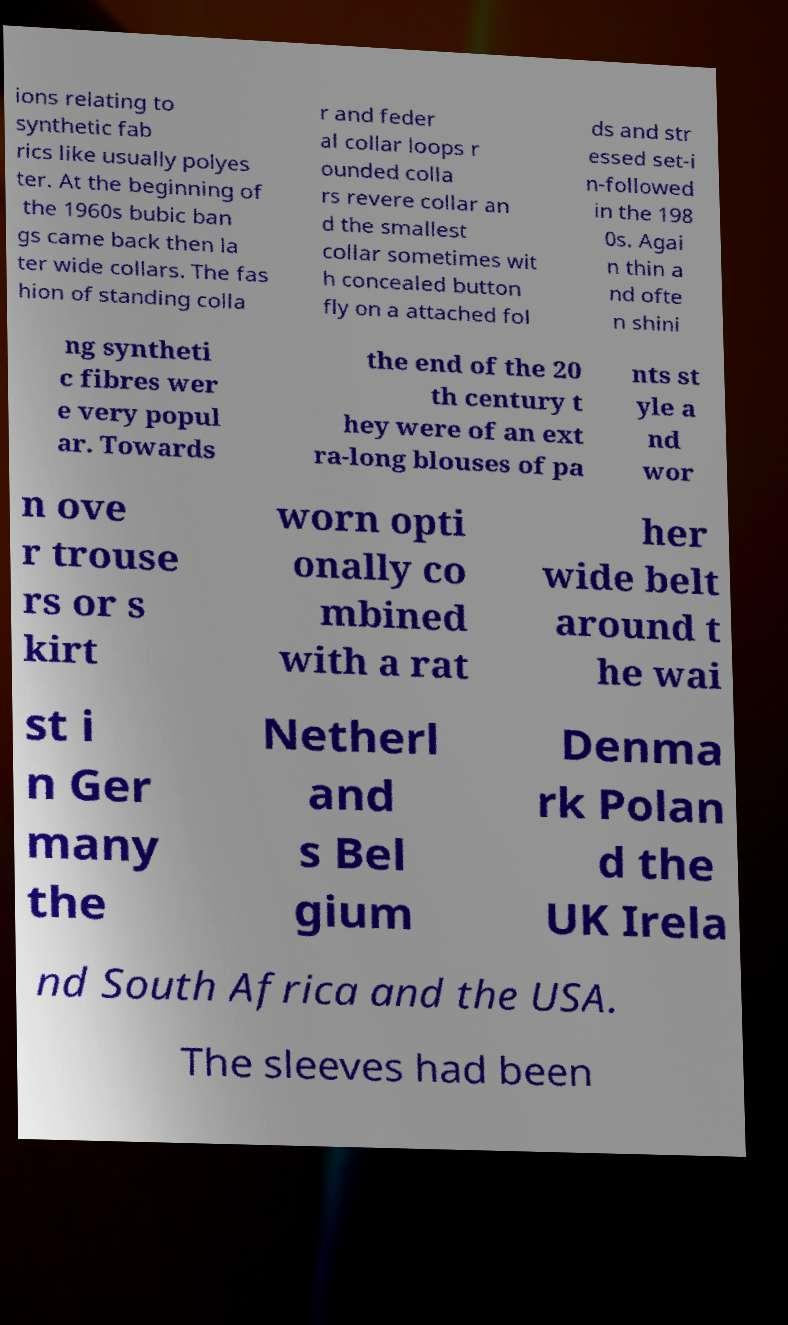Could you extract and type out the text from this image? ions relating to synthetic fab rics like usually polyes ter. At the beginning of the 1960s bubic ban gs came back then la ter wide collars. The fas hion of standing colla r and feder al collar loops r ounded colla rs revere collar an d the smallest collar sometimes wit h concealed button fly on a attached fol ds and str essed set-i n-followed in the 198 0s. Agai n thin a nd ofte n shini ng syntheti c fibres wer e very popul ar. Towards the end of the 20 th century t hey were of an ext ra-long blouses of pa nts st yle a nd wor n ove r trouse rs or s kirt worn opti onally co mbined with a rat her wide belt around t he wai st i n Ger many the Netherl and s Bel gium Denma rk Polan d the UK Irela nd South Africa and the USA. The sleeves had been 